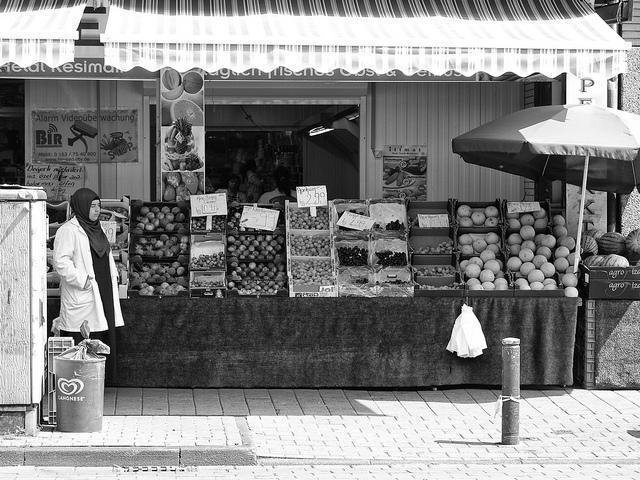How many arched windows are there to the left of the clock tower?
Give a very brief answer. 0. 